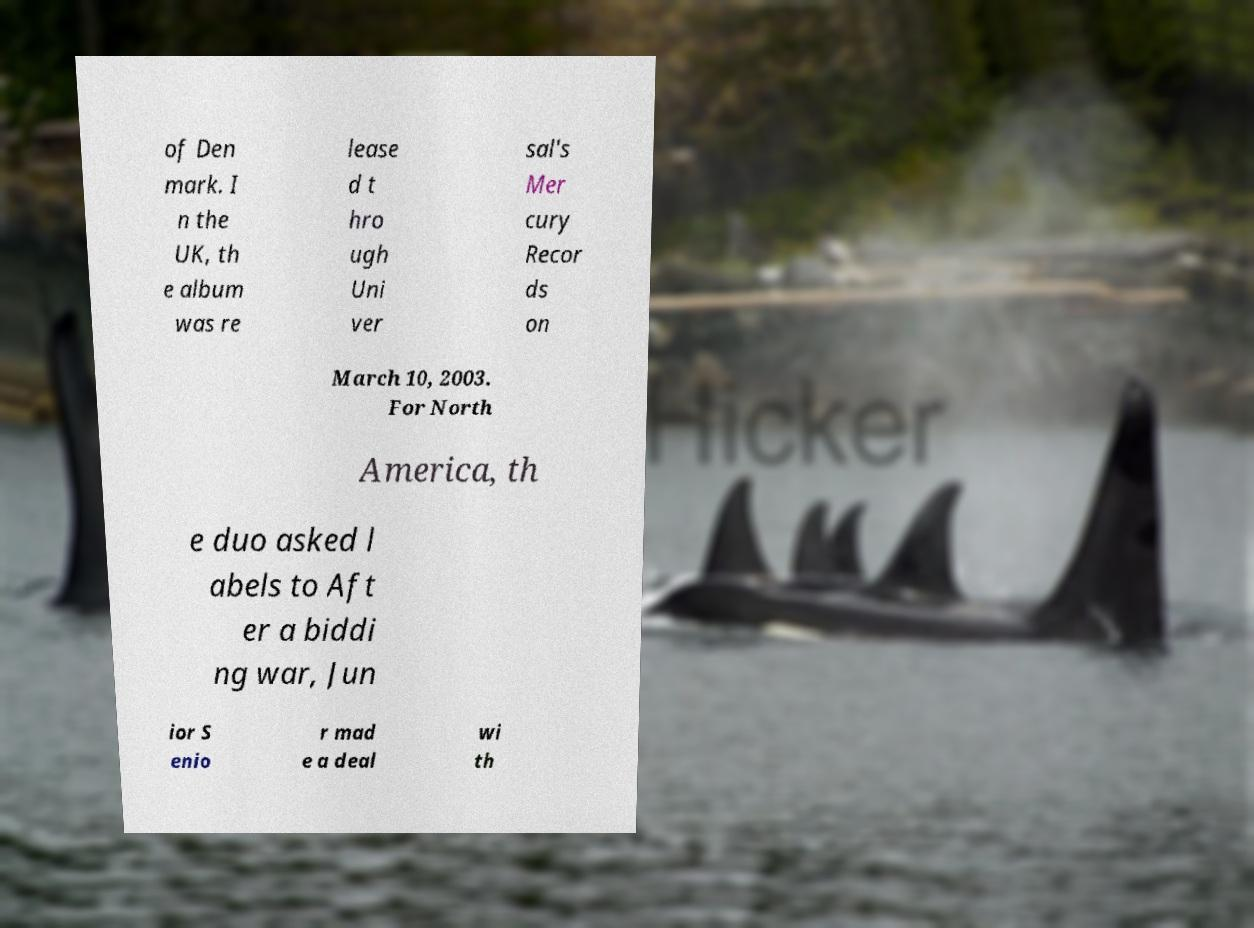For documentation purposes, I need the text within this image transcribed. Could you provide that? of Den mark. I n the UK, th e album was re lease d t hro ugh Uni ver sal's Mer cury Recor ds on March 10, 2003. For North America, th e duo asked l abels to Aft er a biddi ng war, Jun ior S enio r mad e a deal wi th 